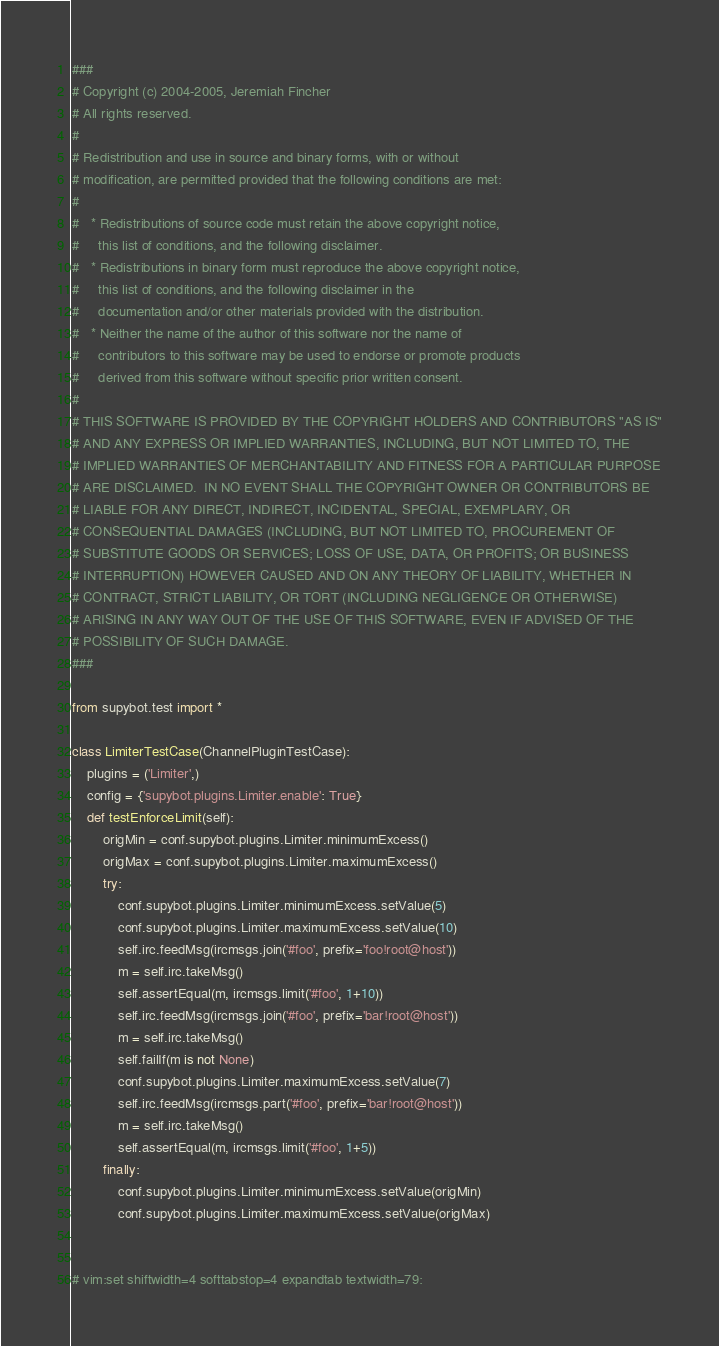<code> <loc_0><loc_0><loc_500><loc_500><_Python_>###
# Copyright (c) 2004-2005, Jeremiah Fincher
# All rights reserved.
#
# Redistribution and use in source and binary forms, with or without
# modification, are permitted provided that the following conditions are met:
#
#   * Redistributions of source code must retain the above copyright notice,
#     this list of conditions, and the following disclaimer.
#   * Redistributions in binary form must reproduce the above copyright notice,
#     this list of conditions, and the following disclaimer in the
#     documentation and/or other materials provided with the distribution.
#   * Neither the name of the author of this software nor the name of
#     contributors to this software may be used to endorse or promote products
#     derived from this software without specific prior written consent.
#
# THIS SOFTWARE IS PROVIDED BY THE COPYRIGHT HOLDERS AND CONTRIBUTORS "AS IS"
# AND ANY EXPRESS OR IMPLIED WARRANTIES, INCLUDING, BUT NOT LIMITED TO, THE
# IMPLIED WARRANTIES OF MERCHANTABILITY AND FITNESS FOR A PARTICULAR PURPOSE
# ARE DISCLAIMED.  IN NO EVENT SHALL THE COPYRIGHT OWNER OR CONTRIBUTORS BE
# LIABLE FOR ANY DIRECT, INDIRECT, INCIDENTAL, SPECIAL, EXEMPLARY, OR
# CONSEQUENTIAL DAMAGES (INCLUDING, BUT NOT LIMITED TO, PROCUREMENT OF
# SUBSTITUTE GOODS OR SERVICES; LOSS OF USE, DATA, OR PROFITS; OR BUSINESS
# INTERRUPTION) HOWEVER CAUSED AND ON ANY THEORY OF LIABILITY, WHETHER IN
# CONTRACT, STRICT LIABILITY, OR TORT (INCLUDING NEGLIGENCE OR OTHERWISE)
# ARISING IN ANY WAY OUT OF THE USE OF THIS SOFTWARE, EVEN IF ADVISED OF THE
# POSSIBILITY OF SUCH DAMAGE.
###

from supybot.test import *

class LimiterTestCase(ChannelPluginTestCase):
    plugins = ('Limiter',)
    config = {'supybot.plugins.Limiter.enable': True}
    def testEnforceLimit(self):
        origMin = conf.supybot.plugins.Limiter.minimumExcess()
        origMax = conf.supybot.plugins.Limiter.maximumExcess()
        try:
            conf.supybot.plugins.Limiter.minimumExcess.setValue(5)
            conf.supybot.plugins.Limiter.maximumExcess.setValue(10)
            self.irc.feedMsg(ircmsgs.join('#foo', prefix='foo!root@host'))
            m = self.irc.takeMsg()
            self.assertEqual(m, ircmsgs.limit('#foo', 1+10))
            self.irc.feedMsg(ircmsgs.join('#foo', prefix='bar!root@host'))
            m = self.irc.takeMsg()
            self.failIf(m is not None)
            conf.supybot.plugins.Limiter.maximumExcess.setValue(7)
            self.irc.feedMsg(ircmsgs.part('#foo', prefix='bar!root@host'))
            m = self.irc.takeMsg()
            self.assertEqual(m, ircmsgs.limit('#foo', 1+5))
        finally:
            conf.supybot.plugins.Limiter.minimumExcess.setValue(origMin)
            conf.supybot.plugins.Limiter.maximumExcess.setValue(origMax)


# vim:set shiftwidth=4 softtabstop=4 expandtab textwidth=79:
</code> 